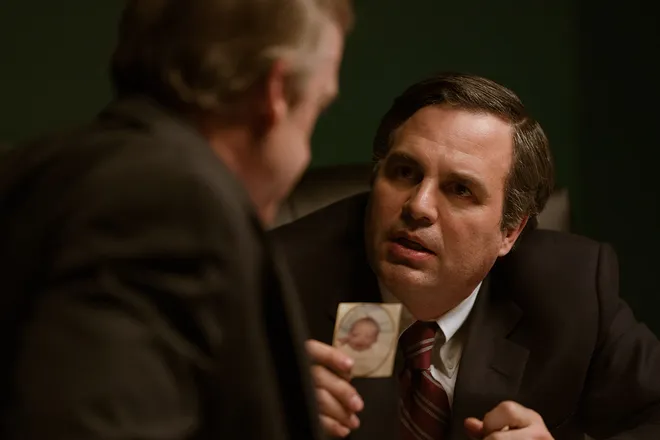What do you think the photograph the man is holding might represent? While the contents of the photograph are not clear from this angle, it seems to be an integral part of the conversation. In storytelling, a held photograph can represent a shared memory, a piece of evidence, or an important clue that might hold significance to the narrative. In this context, it could be a catalyst for the intense exchange between the two individuals. What do their suits tell us about the setting? Their dark suits suggest a formal or professional setting, which could be a workplace, a legal setting, or a corporate environment. The attire indicates that the men are likely involved in a matter that requires a level of seriousness and formality, befitting their professional dress. 